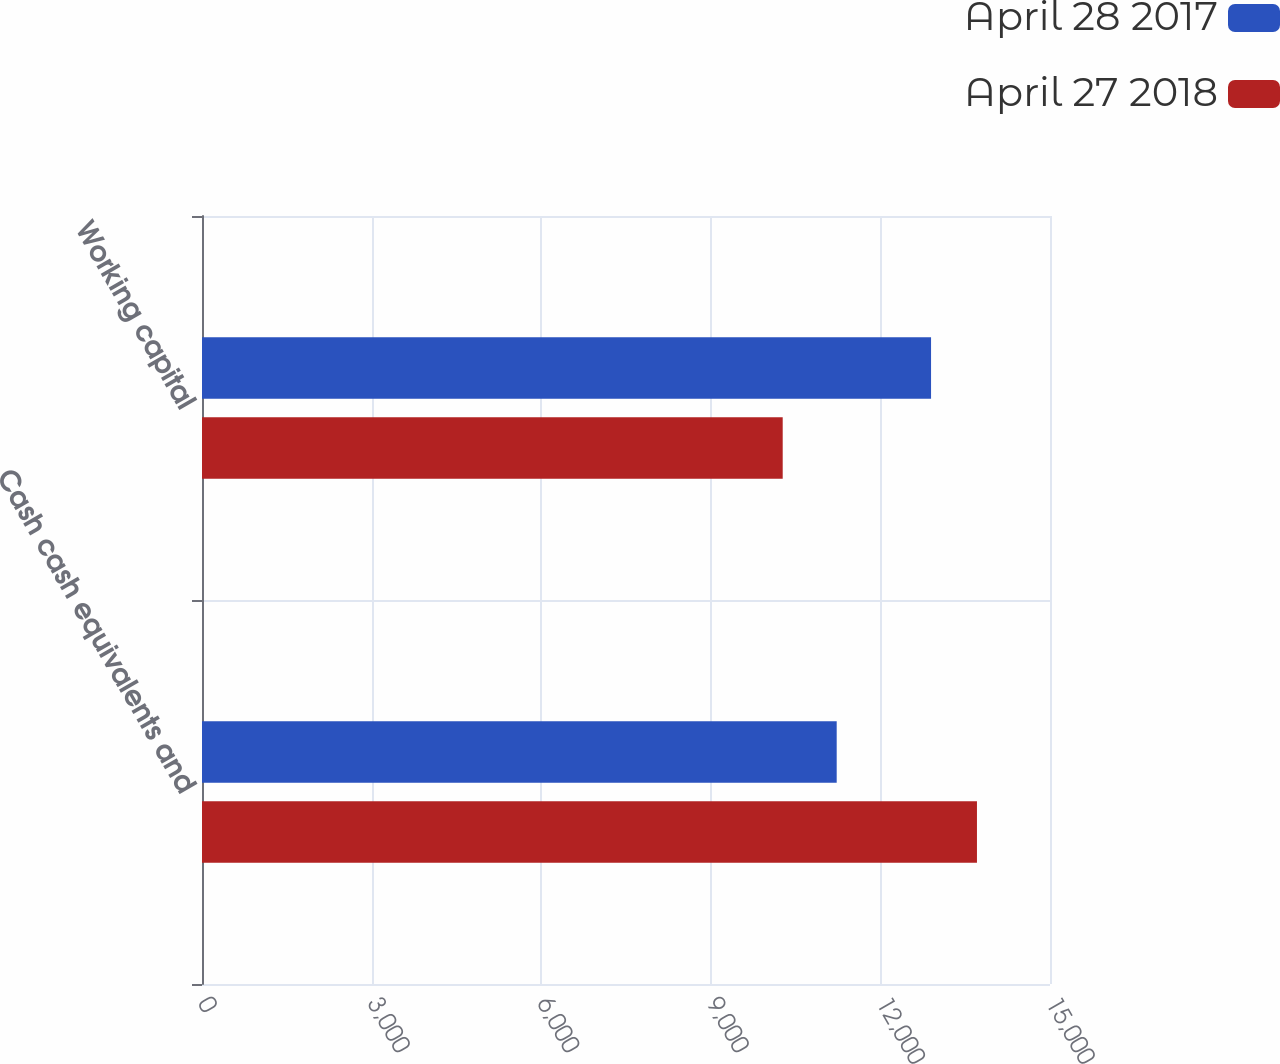Convert chart to OTSL. <chart><loc_0><loc_0><loc_500><loc_500><stacked_bar_chart><ecel><fcel>Cash cash equivalents and<fcel>Working capital<nl><fcel>April 28 2017<fcel>11227<fcel>12896<nl><fcel>April 27 2018<fcel>13708<fcel>10272<nl></chart> 